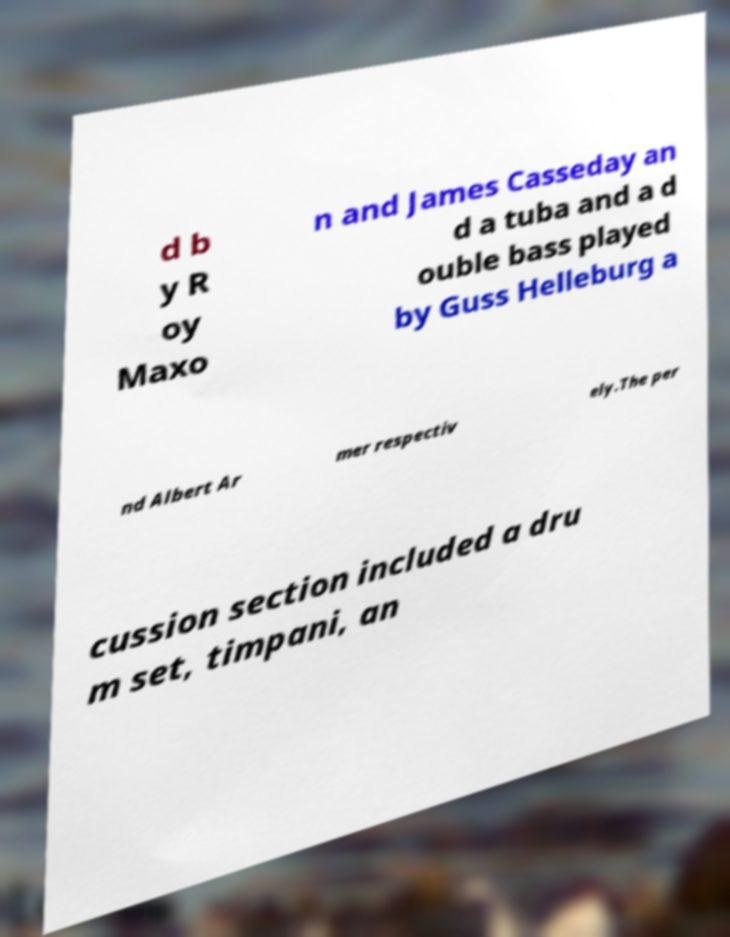Could you extract and type out the text from this image? d b y R oy Maxo n and James Casseday an d a tuba and a d ouble bass played by Guss Helleburg a nd Albert Ar mer respectiv ely.The per cussion section included a dru m set, timpani, an 